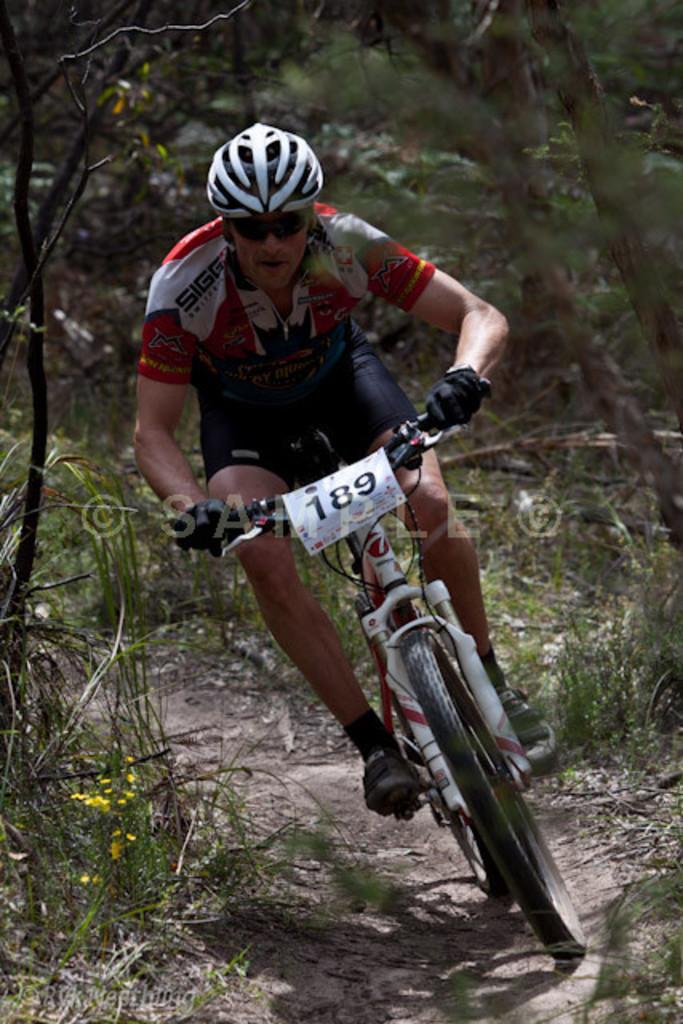Please provide a concise description of this image. In this picture we can see a man wore a helmet, goggles, shoes and riding a bicycle on the ground and in the background we can see trees. 